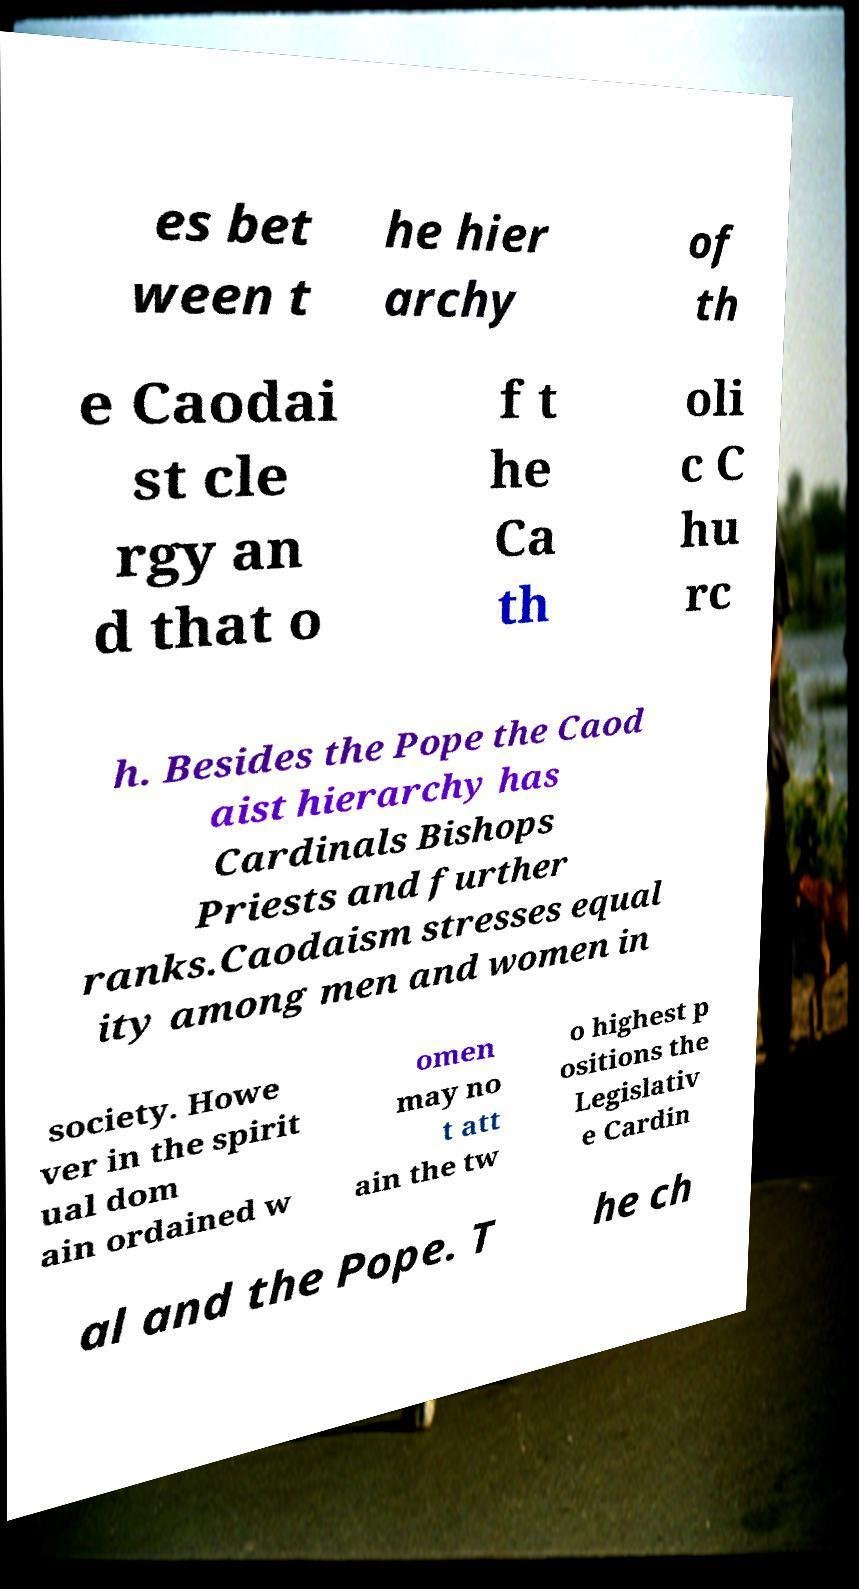Could you assist in decoding the text presented in this image and type it out clearly? es bet ween t he hier archy of th e Caodai st cle rgy an d that o f t he Ca th oli c C hu rc h. Besides the Pope the Caod aist hierarchy has Cardinals Bishops Priests and further ranks.Caodaism stresses equal ity among men and women in society. Howe ver in the spirit ual dom ain ordained w omen may no t att ain the tw o highest p ositions the Legislativ e Cardin al and the Pope. T he ch 